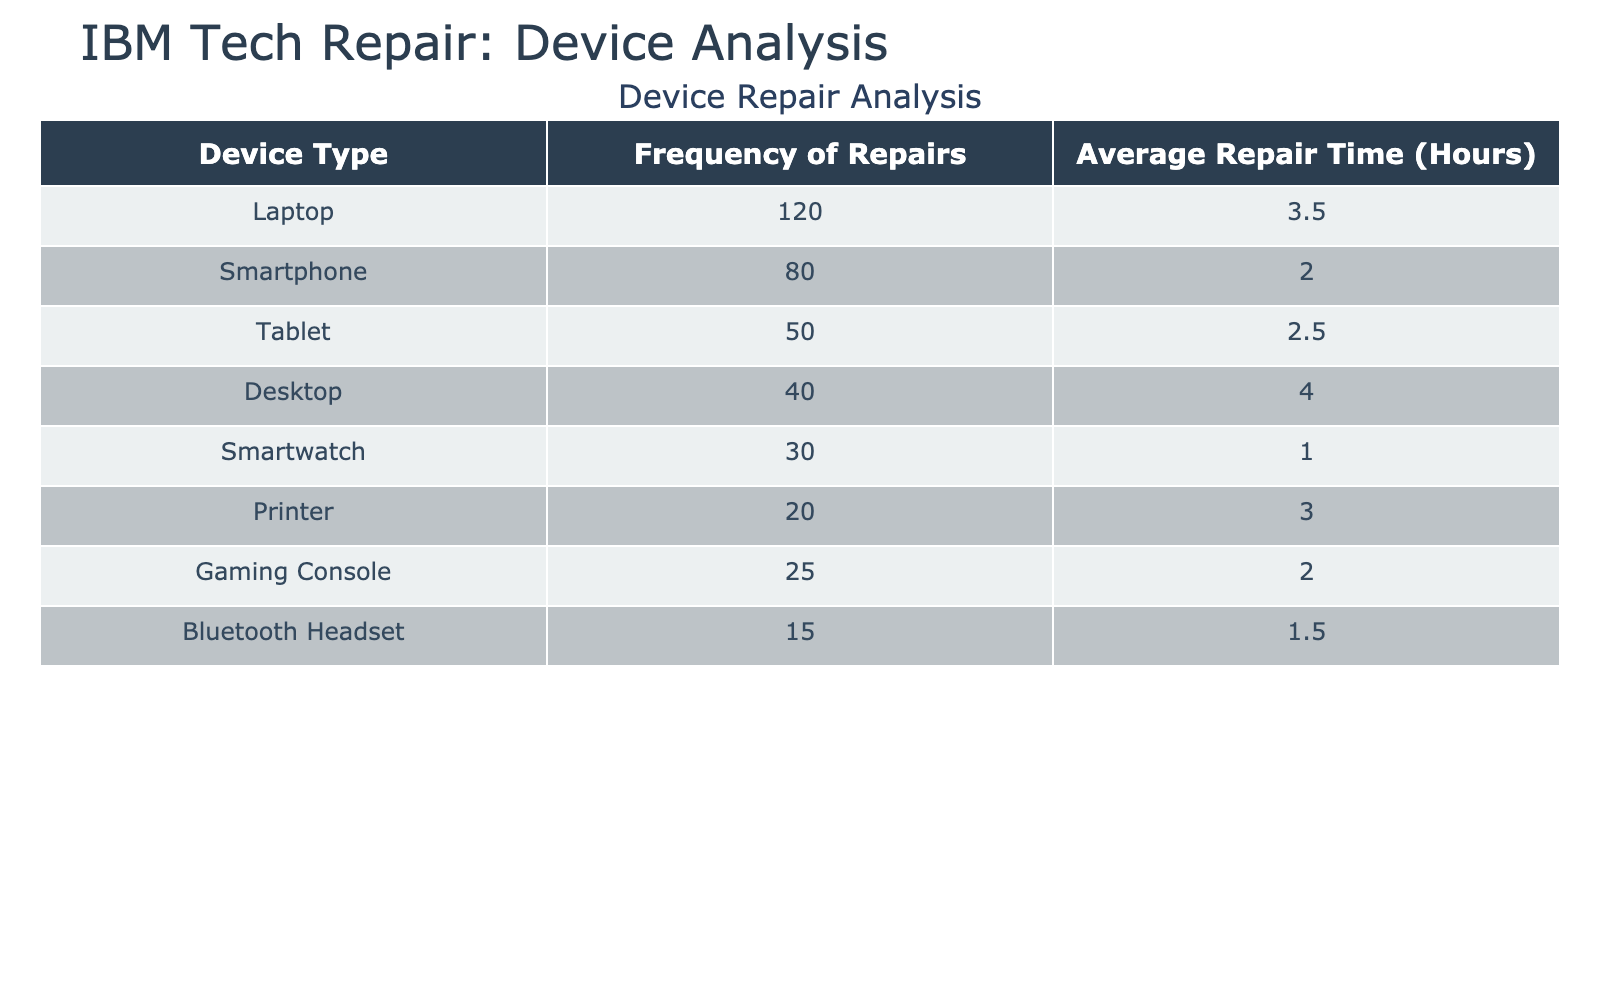What device type had the highest frequency of repairs? The table shows that laptops had the highest frequency of repairs at 120.
Answer: Laptops What is the average repair time for smartphones? The table indicates that the average repair time for smartphones is 2.0 hours.
Answer: 2.0 hours Which device type has the lowest average repair time? According to the table, smartwatches have the lowest average repair time of 1.0 hour.
Answer: Smartwatches What is the total frequency of repairs for tablets and printers combined? To find the total frequency for tablets (50) and printers (20), add them: 50 + 20 = 70.
Answer: 70 Is the average repair time for desktops greater than 3 hours? The average repair time for desktops is listed as 4.0 hours, which is indeed greater than 3 hours.
Answer: Yes How many more repairs were done for laptops than for gaming consoles? Laptops had 120 repairs, while gaming consoles had 25. The difference is 120 - 25 = 95.
Answer: 95 more What is the average repair time across all device types? To find the average, sum the average repair times: (3.5 + 2.0 + 2.5 + 4.0 + 1.0 + 3.0 + 2.0 + 1.5) = 19.5, then divide by the number of device types (8) = 19.5 / 8 = 2.4375.
Answer: 2.4375 hours Do both printers and smartwatches have an average repair time of less than 2 hours? Printers have an average repair time of 3.0 hours, which is greater than 2, while smartwatches have 1.0 hour, which is less than 2. Therefore, it is false for both.
Answer: No What proportion of total repairs were for smartphones? The total repairs can be calculated by summing all frequencies: 120 + 80 + 50 + 40 + 30 + 20 + 25 + 15 = 370. The proportion for smartphones is 80 / 370, which is approximately 0.216 or 21.6%.
Answer: 21.6% 